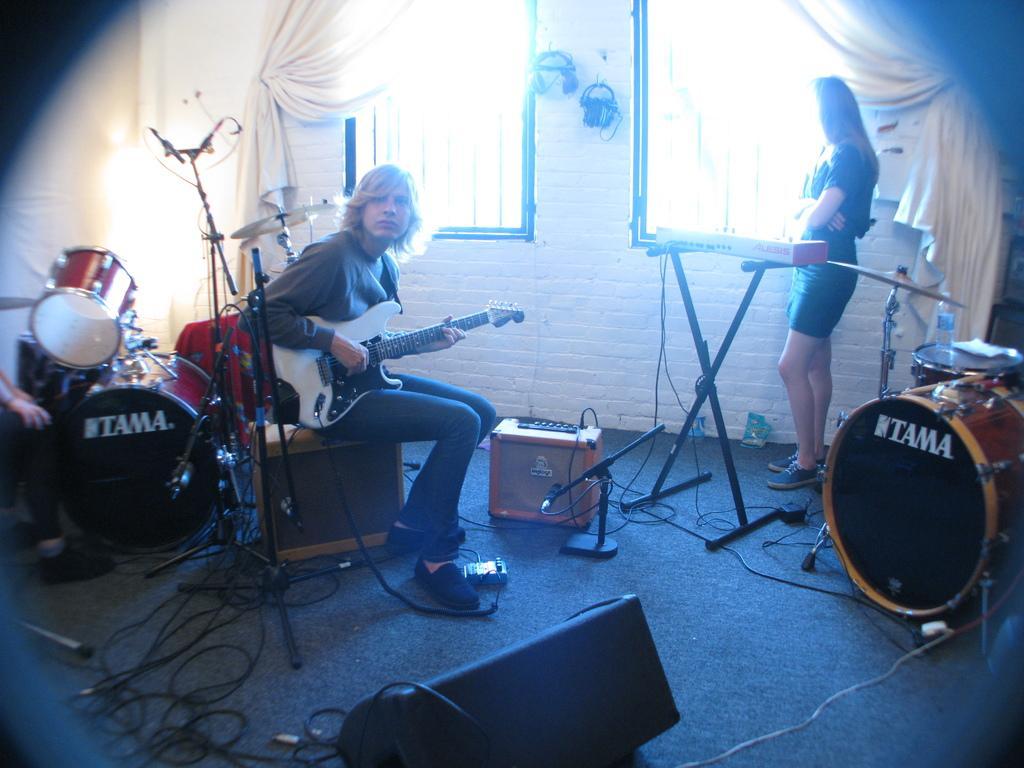Please provide a concise description of this image. In this image, In the middle there is a boy sitting and he is holding a music instrument which is in white color, There are some music instruments which are in yellow and black colors, In the right side there is a girl she is standing and there are some windows in white color and there is a curtain which is in white color. 